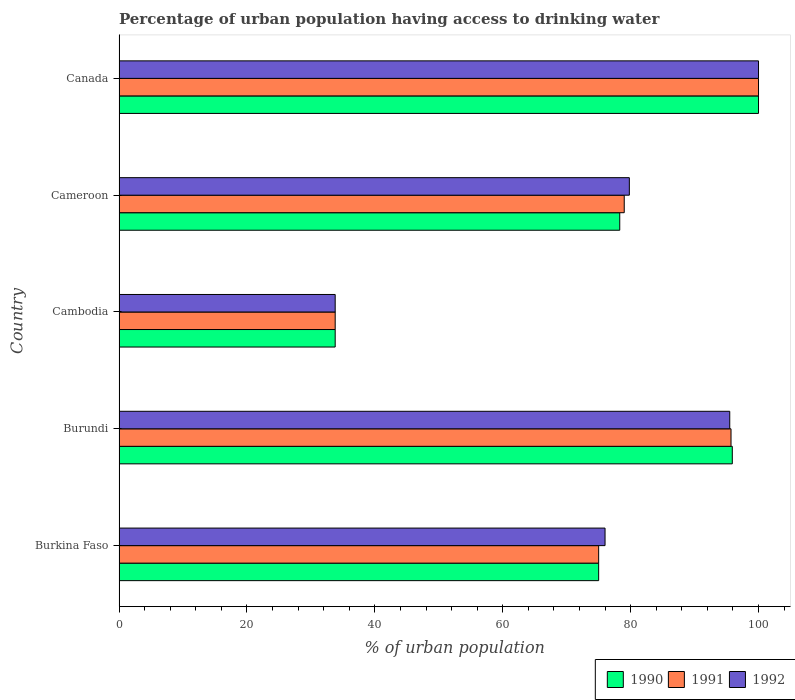Are the number of bars per tick equal to the number of legend labels?
Provide a succinct answer. Yes. Are the number of bars on each tick of the Y-axis equal?
Offer a terse response. Yes. How many bars are there on the 2nd tick from the top?
Your answer should be very brief. 3. How many bars are there on the 5th tick from the bottom?
Ensure brevity in your answer.  3. What is the label of the 2nd group of bars from the top?
Provide a succinct answer. Cameroon. What is the percentage of urban population having access to drinking water in 1991 in Cameroon?
Provide a short and direct response. 79. Across all countries, what is the maximum percentage of urban population having access to drinking water in 1991?
Your answer should be very brief. 100. Across all countries, what is the minimum percentage of urban population having access to drinking water in 1990?
Provide a succinct answer. 33.8. In which country was the percentage of urban population having access to drinking water in 1990 minimum?
Ensure brevity in your answer.  Cambodia. What is the total percentage of urban population having access to drinking water in 1992 in the graph?
Give a very brief answer. 385.1. What is the difference between the percentage of urban population having access to drinking water in 1992 in Cameroon and that in Canada?
Give a very brief answer. -20.2. What is the difference between the percentage of urban population having access to drinking water in 1990 in Canada and the percentage of urban population having access to drinking water in 1991 in Cambodia?
Your answer should be compact. 66.2. What is the average percentage of urban population having access to drinking water in 1992 per country?
Keep it short and to the point. 77.02. What is the difference between the percentage of urban population having access to drinking water in 1991 and percentage of urban population having access to drinking water in 1990 in Canada?
Your answer should be very brief. 0. What is the ratio of the percentage of urban population having access to drinking water in 1992 in Burundi to that in Cameroon?
Make the answer very short. 1.2. Is the percentage of urban population having access to drinking water in 1991 in Burundi less than that in Cameroon?
Make the answer very short. No. What is the difference between the highest and the lowest percentage of urban population having access to drinking water in 1991?
Your response must be concise. 66.2. Is the sum of the percentage of urban population having access to drinking water in 1990 in Cambodia and Canada greater than the maximum percentage of urban population having access to drinking water in 1991 across all countries?
Ensure brevity in your answer.  Yes. What does the 1st bar from the top in Burkina Faso represents?
Your answer should be compact. 1992. What does the 2nd bar from the bottom in Burundi represents?
Provide a succinct answer. 1991. Is it the case that in every country, the sum of the percentage of urban population having access to drinking water in 1992 and percentage of urban population having access to drinking water in 1991 is greater than the percentage of urban population having access to drinking water in 1990?
Give a very brief answer. Yes. How many bars are there?
Offer a very short reply. 15. Are all the bars in the graph horizontal?
Keep it short and to the point. Yes. What is the difference between two consecutive major ticks on the X-axis?
Your response must be concise. 20. Are the values on the major ticks of X-axis written in scientific E-notation?
Give a very brief answer. No. Does the graph contain any zero values?
Your response must be concise. No. Does the graph contain grids?
Offer a terse response. No. What is the title of the graph?
Your answer should be very brief. Percentage of urban population having access to drinking water. What is the label or title of the X-axis?
Ensure brevity in your answer.  % of urban population. What is the % of urban population of 1990 in Burkina Faso?
Your response must be concise. 75. What is the % of urban population of 1991 in Burkina Faso?
Keep it short and to the point. 75. What is the % of urban population in 1990 in Burundi?
Your answer should be compact. 95.9. What is the % of urban population in 1991 in Burundi?
Provide a succinct answer. 95.7. What is the % of urban population of 1992 in Burundi?
Keep it short and to the point. 95.5. What is the % of urban population of 1990 in Cambodia?
Keep it short and to the point. 33.8. What is the % of urban population of 1991 in Cambodia?
Your response must be concise. 33.8. What is the % of urban population of 1992 in Cambodia?
Make the answer very short. 33.8. What is the % of urban population in 1990 in Cameroon?
Make the answer very short. 78.3. What is the % of urban population in 1991 in Cameroon?
Offer a very short reply. 79. What is the % of urban population in 1992 in Cameroon?
Ensure brevity in your answer.  79.8. What is the % of urban population in 1991 in Canada?
Your answer should be compact. 100. What is the % of urban population of 1992 in Canada?
Provide a short and direct response. 100. Across all countries, what is the maximum % of urban population of 1990?
Your answer should be compact. 100. Across all countries, what is the maximum % of urban population in 1992?
Provide a short and direct response. 100. Across all countries, what is the minimum % of urban population in 1990?
Keep it short and to the point. 33.8. Across all countries, what is the minimum % of urban population in 1991?
Provide a succinct answer. 33.8. Across all countries, what is the minimum % of urban population of 1992?
Provide a short and direct response. 33.8. What is the total % of urban population in 1990 in the graph?
Provide a succinct answer. 383. What is the total % of urban population in 1991 in the graph?
Make the answer very short. 383.5. What is the total % of urban population of 1992 in the graph?
Offer a very short reply. 385.1. What is the difference between the % of urban population in 1990 in Burkina Faso and that in Burundi?
Keep it short and to the point. -20.9. What is the difference between the % of urban population of 1991 in Burkina Faso and that in Burundi?
Your answer should be compact. -20.7. What is the difference between the % of urban population of 1992 in Burkina Faso and that in Burundi?
Ensure brevity in your answer.  -19.5. What is the difference between the % of urban population of 1990 in Burkina Faso and that in Cambodia?
Keep it short and to the point. 41.2. What is the difference between the % of urban population of 1991 in Burkina Faso and that in Cambodia?
Your answer should be compact. 41.2. What is the difference between the % of urban population in 1992 in Burkina Faso and that in Cambodia?
Provide a short and direct response. 42.2. What is the difference between the % of urban population of 1992 in Burkina Faso and that in Cameroon?
Keep it short and to the point. -3.8. What is the difference between the % of urban population in 1990 in Burkina Faso and that in Canada?
Offer a terse response. -25. What is the difference between the % of urban population of 1992 in Burkina Faso and that in Canada?
Offer a terse response. -24. What is the difference between the % of urban population in 1990 in Burundi and that in Cambodia?
Ensure brevity in your answer.  62.1. What is the difference between the % of urban population in 1991 in Burundi and that in Cambodia?
Offer a terse response. 61.9. What is the difference between the % of urban population of 1992 in Burundi and that in Cambodia?
Give a very brief answer. 61.7. What is the difference between the % of urban population in 1991 in Burundi and that in Cameroon?
Offer a very short reply. 16.7. What is the difference between the % of urban population in 1991 in Burundi and that in Canada?
Ensure brevity in your answer.  -4.3. What is the difference between the % of urban population in 1990 in Cambodia and that in Cameroon?
Offer a terse response. -44.5. What is the difference between the % of urban population in 1991 in Cambodia and that in Cameroon?
Make the answer very short. -45.2. What is the difference between the % of urban population in 1992 in Cambodia and that in Cameroon?
Your answer should be very brief. -46. What is the difference between the % of urban population of 1990 in Cambodia and that in Canada?
Your response must be concise. -66.2. What is the difference between the % of urban population in 1991 in Cambodia and that in Canada?
Provide a short and direct response. -66.2. What is the difference between the % of urban population of 1992 in Cambodia and that in Canada?
Make the answer very short. -66.2. What is the difference between the % of urban population in 1990 in Cameroon and that in Canada?
Make the answer very short. -21.7. What is the difference between the % of urban population of 1991 in Cameroon and that in Canada?
Your response must be concise. -21. What is the difference between the % of urban population of 1992 in Cameroon and that in Canada?
Keep it short and to the point. -20.2. What is the difference between the % of urban population of 1990 in Burkina Faso and the % of urban population of 1991 in Burundi?
Offer a very short reply. -20.7. What is the difference between the % of urban population of 1990 in Burkina Faso and the % of urban population of 1992 in Burundi?
Make the answer very short. -20.5. What is the difference between the % of urban population of 1991 in Burkina Faso and the % of urban population of 1992 in Burundi?
Provide a short and direct response. -20.5. What is the difference between the % of urban population of 1990 in Burkina Faso and the % of urban population of 1991 in Cambodia?
Provide a succinct answer. 41.2. What is the difference between the % of urban population of 1990 in Burkina Faso and the % of urban population of 1992 in Cambodia?
Provide a succinct answer. 41.2. What is the difference between the % of urban population in 1991 in Burkina Faso and the % of urban population in 1992 in Cambodia?
Your answer should be very brief. 41.2. What is the difference between the % of urban population of 1990 in Burkina Faso and the % of urban population of 1991 in Cameroon?
Ensure brevity in your answer.  -4. What is the difference between the % of urban population in 1990 in Burkina Faso and the % of urban population in 1992 in Cameroon?
Your answer should be compact. -4.8. What is the difference between the % of urban population of 1991 in Burkina Faso and the % of urban population of 1992 in Cameroon?
Ensure brevity in your answer.  -4.8. What is the difference between the % of urban population of 1990 in Burkina Faso and the % of urban population of 1992 in Canada?
Your response must be concise. -25. What is the difference between the % of urban population in 1990 in Burundi and the % of urban population in 1991 in Cambodia?
Offer a very short reply. 62.1. What is the difference between the % of urban population of 1990 in Burundi and the % of urban population of 1992 in Cambodia?
Your answer should be compact. 62.1. What is the difference between the % of urban population in 1991 in Burundi and the % of urban population in 1992 in Cambodia?
Offer a very short reply. 61.9. What is the difference between the % of urban population in 1990 in Burundi and the % of urban population in 1992 in Cameroon?
Make the answer very short. 16.1. What is the difference between the % of urban population in 1991 in Burundi and the % of urban population in 1992 in Cameroon?
Provide a succinct answer. 15.9. What is the difference between the % of urban population of 1990 in Burundi and the % of urban population of 1992 in Canada?
Keep it short and to the point. -4.1. What is the difference between the % of urban population of 1991 in Burundi and the % of urban population of 1992 in Canada?
Your answer should be very brief. -4.3. What is the difference between the % of urban population of 1990 in Cambodia and the % of urban population of 1991 in Cameroon?
Offer a terse response. -45.2. What is the difference between the % of urban population of 1990 in Cambodia and the % of urban population of 1992 in Cameroon?
Offer a terse response. -46. What is the difference between the % of urban population in 1991 in Cambodia and the % of urban population in 1992 in Cameroon?
Your response must be concise. -46. What is the difference between the % of urban population in 1990 in Cambodia and the % of urban population in 1991 in Canada?
Offer a very short reply. -66.2. What is the difference between the % of urban population in 1990 in Cambodia and the % of urban population in 1992 in Canada?
Your answer should be compact. -66.2. What is the difference between the % of urban population of 1991 in Cambodia and the % of urban population of 1992 in Canada?
Keep it short and to the point. -66.2. What is the difference between the % of urban population in 1990 in Cameroon and the % of urban population in 1991 in Canada?
Provide a succinct answer. -21.7. What is the difference between the % of urban population of 1990 in Cameroon and the % of urban population of 1992 in Canada?
Offer a very short reply. -21.7. What is the difference between the % of urban population of 1991 in Cameroon and the % of urban population of 1992 in Canada?
Keep it short and to the point. -21. What is the average % of urban population of 1990 per country?
Your answer should be compact. 76.6. What is the average % of urban population in 1991 per country?
Offer a very short reply. 76.7. What is the average % of urban population of 1992 per country?
Make the answer very short. 77.02. What is the difference between the % of urban population in 1990 and % of urban population in 1991 in Burkina Faso?
Give a very brief answer. 0. What is the difference between the % of urban population of 1990 and % of urban population of 1992 in Burkina Faso?
Keep it short and to the point. -1. What is the difference between the % of urban population in 1991 and % of urban population in 1992 in Burkina Faso?
Ensure brevity in your answer.  -1. What is the difference between the % of urban population in 1990 and % of urban population in 1992 in Cambodia?
Your answer should be compact. 0. What is the difference between the % of urban population in 1990 and % of urban population in 1991 in Cameroon?
Provide a short and direct response. -0.7. What is the difference between the % of urban population in 1990 and % of urban population in 1991 in Canada?
Ensure brevity in your answer.  0. What is the difference between the % of urban population in 1990 and % of urban population in 1992 in Canada?
Provide a short and direct response. 0. What is the difference between the % of urban population of 1991 and % of urban population of 1992 in Canada?
Make the answer very short. 0. What is the ratio of the % of urban population in 1990 in Burkina Faso to that in Burundi?
Ensure brevity in your answer.  0.78. What is the ratio of the % of urban population in 1991 in Burkina Faso to that in Burundi?
Offer a terse response. 0.78. What is the ratio of the % of urban population in 1992 in Burkina Faso to that in Burundi?
Give a very brief answer. 0.8. What is the ratio of the % of urban population of 1990 in Burkina Faso to that in Cambodia?
Offer a very short reply. 2.22. What is the ratio of the % of urban population in 1991 in Burkina Faso to that in Cambodia?
Offer a terse response. 2.22. What is the ratio of the % of urban population of 1992 in Burkina Faso to that in Cambodia?
Provide a short and direct response. 2.25. What is the ratio of the % of urban population in 1990 in Burkina Faso to that in Cameroon?
Your answer should be very brief. 0.96. What is the ratio of the % of urban population in 1991 in Burkina Faso to that in Cameroon?
Keep it short and to the point. 0.95. What is the ratio of the % of urban population of 1992 in Burkina Faso to that in Cameroon?
Keep it short and to the point. 0.95. What is the ratio of the % of urban population of 1991 in Burkina Faso to that in Canada?
Make the answer very short. 0.75. What is the ratio of the % of urban population in 1992 in Burkina Faso to that in Canada?
Keep it short and to the point. 0.76. What is the ratio of the % of urban population of 1990 in Burundi to that in Cambodia?
Your answer should be compact. 2.84. What is the ratio of the % of urban population of 1991 in Burundi to that in Cambodia?
Offer a terse response. 2.83. What is the ratio of the % of urban population in 1992 in Burundi to that in Cambodia?
Keep it short and to the point. 2.83. What is the ratio of the % of urban population in 1990 in Burundi to that in Cameroon?
Offer a very short reply. 1.22. What is the ratio of the % of urban population of 1991 in Burundi to that in Cameroon?
Your response must be concise. 1.21. What is the ratio of the % of urban population of 1992 in Burundi to that in Cameroon?
Provide a succinct answer. 1.2. What is the ratio of the % of urban population of 1990 in Burundi to that in Canada?
Keep it short and to the point. 0.96. What is the ratio of the % of urban population of 1992 in Burundi to that in Canada?
Provide a succinct answer. 0.95. What is the ratio of the % of urban population of 1990 in Cambodia to that in Cameroon?
Provide a short and direct response. 0.43. What is the ratio of the % of urban population of 1991 in Cambodia to that in Cameroon?
Keep it short and to the point. 0.43. What is the ratio of the % of urban population in 1992 in Cambodia to that in Cameroon?
Give a very brief answer. 0.42. What is the ratio of the % of urban population of 1990 in Cambodia to that in Canada?
Your answer should be very brief. 0.34. What is the ratio of the % of urban population of 1991 in Cambodia to that in Canada?
Your response must be concise. 0.34. What is the ratio of the % of urban population of 1992 in Cambodia to that in Canada?
Make the answer very short. 0.34. What is the ratio of the % of urban population of 1990 in Cameroon to that in Canada?
Ensure brevity in your answer.  0.78. What is the ratio of the % of urban population of 1991 in Cameroon to that in Canada?
Provide a short and direct response. 0.79. What is the ratio of the % of urban population in 1992 in Cameroon to that in Canada?
Ensure brevity in your answer.  0.8. What is the difference between the highest and the second highest % of urban population of 1991?
Ensure brevity in your answer.  4.3. What is the difference between the highest and the second highest % of urban population in 1992?
Provide a short and direct response. 4.5. What is the difference between the highest and the lowest % of urban population in 1990?
Offer a very short reply. 66.2. What is the difference between the highest and the lowest % of urban population in 1991?
Provide a succinct answer. 66.2. What is the difference between the highest and the lowest % of urban population of 1992?
Offer a very short reply. 66.2. 